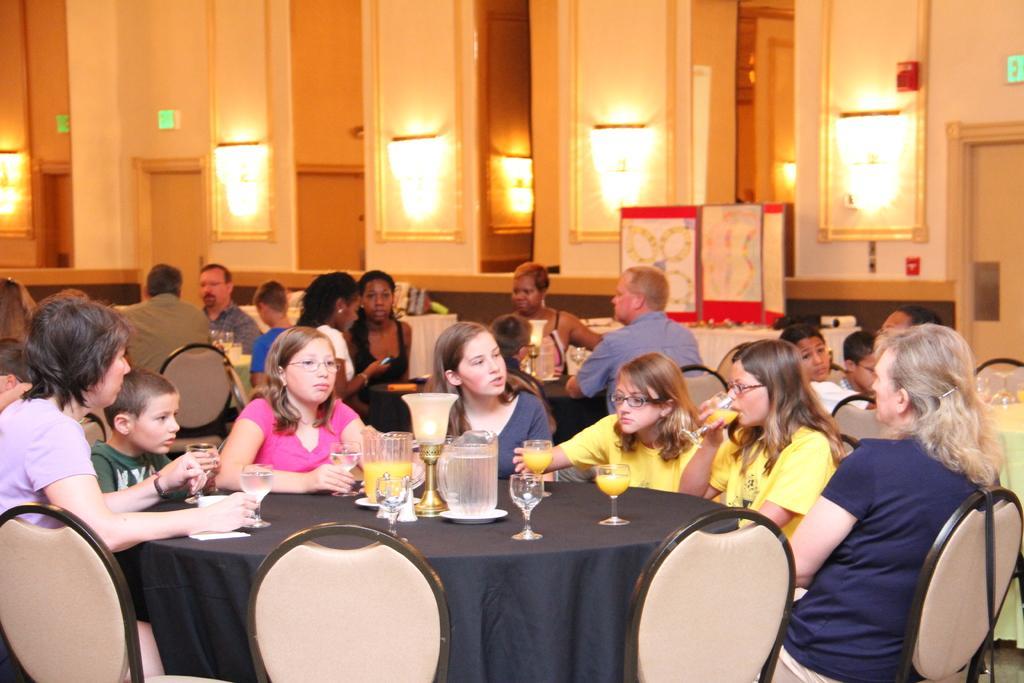Can you describe this image briefly? In this picture we can see a group of people sitting on chairs and in front of them there is table and on table we can see jar, glass, lamp, papers and in background we can see lamp, papers and in background we can see wall, light, banners, door. 